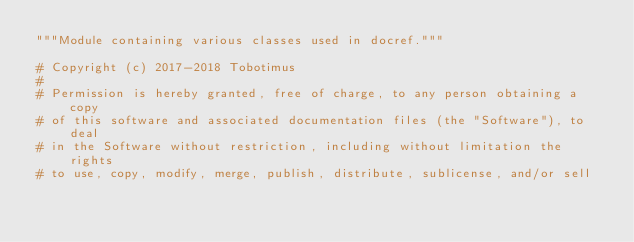Convert code to text. <code><loc_0><loc_0><loc_500><loc_500><_Python_>"""Module containing various classes used in docref."""

# Copyright (c) 2017-2018 Tobotimus
#
# Permission is hereby granted, free of charge, to any person obtaining a copy
# of this software and associated documentation files (the "Software"), to deal
# in the Software without restriction, including without limitation the rights
# to use, copy, modify, merge, publish, distribute, sublicense, and/or sell</code> 